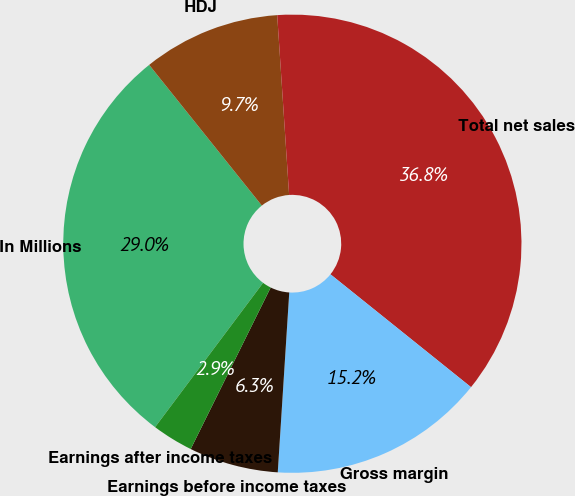Convert chart to OTSL. <chart><loc_0><loc_0><loc_500><loc_500><pie_chart><fcel>In Millions<fcel>HDJ<fcel>Total net sales<fcel>Gross margin<fcel>Earnings before income taxes<fcel>Earnings after income taxes<nl><fcel>29.03%<fcel>9.69%<fcel>36.82%<fcel>15.25%<fcel>6.3%<fcel>2.91%<nl></chart> 